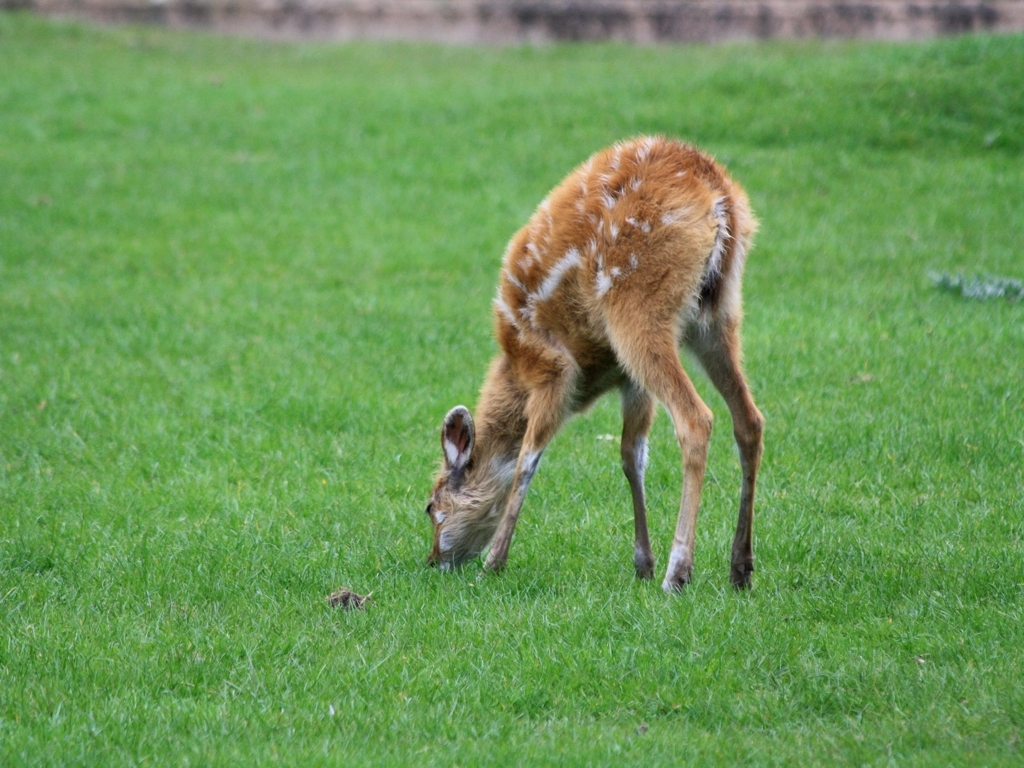Where do you think this image was taken? Considering the grassy field and the absence of any snow or tropical plants, this image might have been taken in a temperate woodland park or a wildlife sanctuary. 